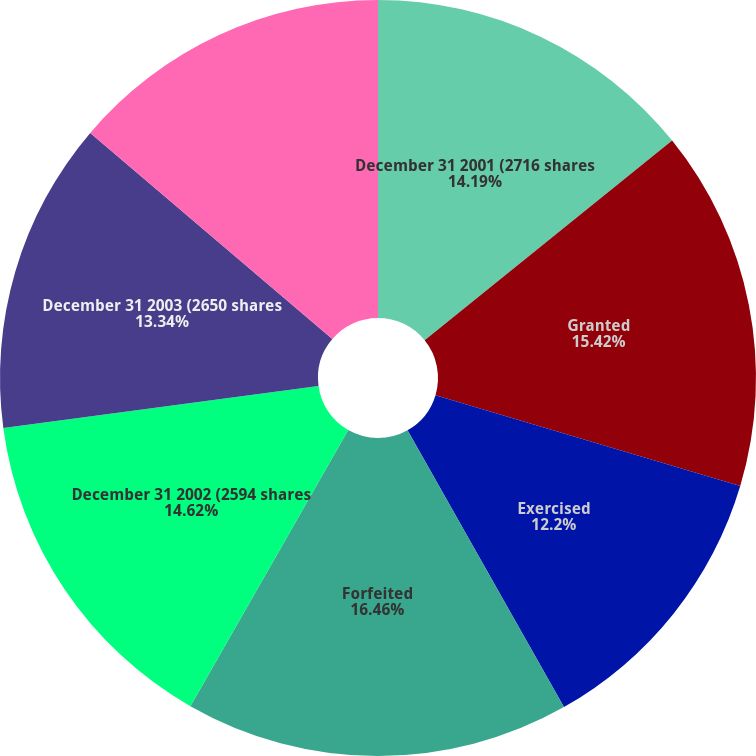Convert chart. <chart><loc_0><loc_0><loc_500><loc_500><pie_chart><fcel>December 31 2001 (2716 shares<fcel>Granted<fcel>Exercised<fcel>Forfeited<fcel>December 31 2002 (2594 shares<fcel>December 31 2003 (2650 shares<fcel>December 31 2004 (1734 shares<nl><fcel>14.19%<fcel>15.42%<fcel>12.2%<fcel>16.45%<fcel>14.62%<fcel>13.34%<fcel>13.77%<nl></chart> 